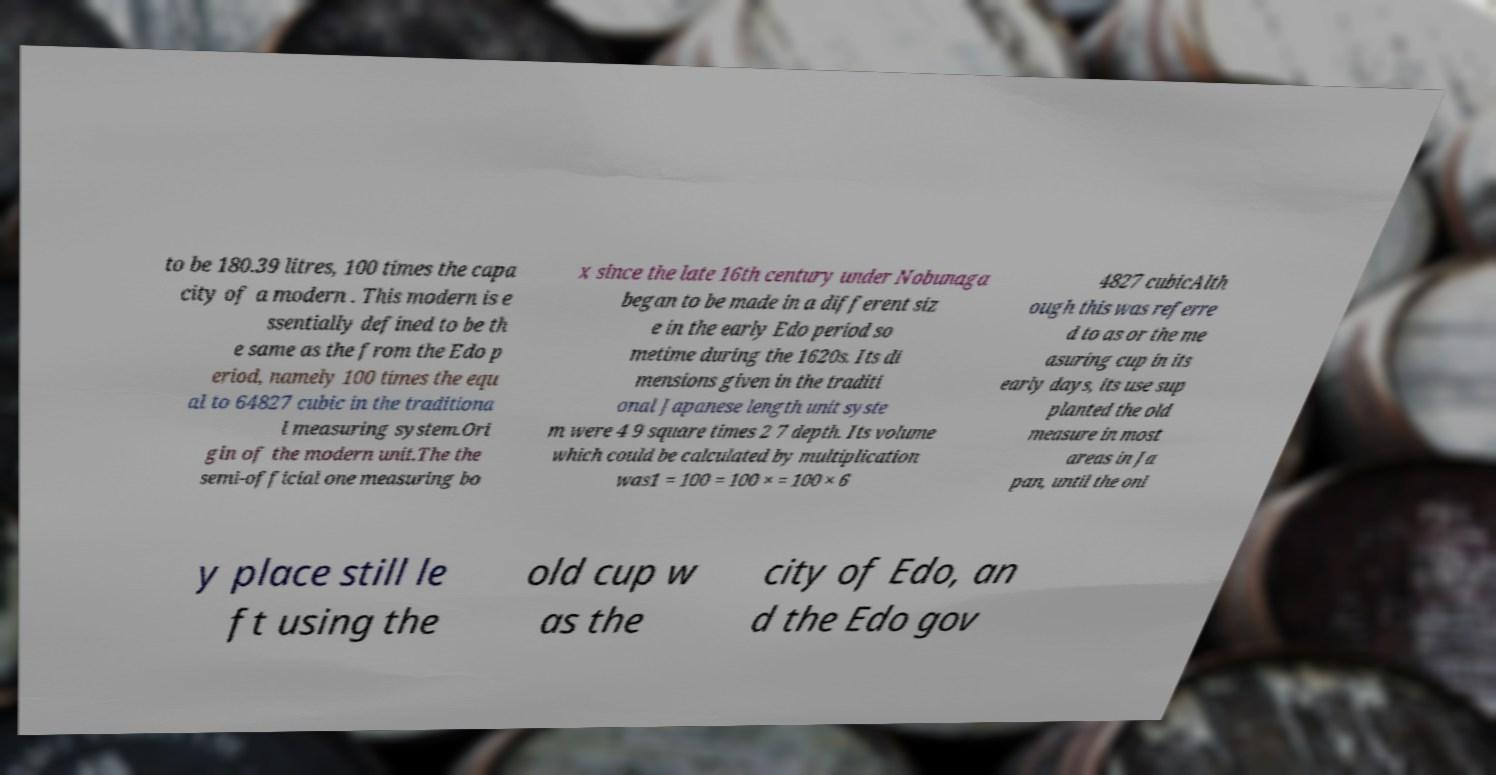Please identify and transcribe the text found in this image. to be 180.39 litres, 100 times the capa city of a modern . This modern is e ssentially defined to be th e same as the from the Edo p eriod, namely 100 times the equ al to 64827 cubic in the traditiona l measuring system.Ori gin of the modern unit.The the semi-official one measuring bo x since the late 16th century under Nobunaga began to be made in a different siz e in the early Edo period so metime during the 1620s. Its di mensions given in the traditi onal Japanese length unit syste m were 4 9 square times 2 7 depth. Its volume which could be calculated by multiplication was1 = 100 = 100 × = 100 × 6 4827 cubicAlth ough this was referre d to as or the me asuring cup in its early days, its use sup planted the old measure in most areas in Ja pan, until the onl y place still le ft using the old cup w as the city of Edo, an d the Edo gov 